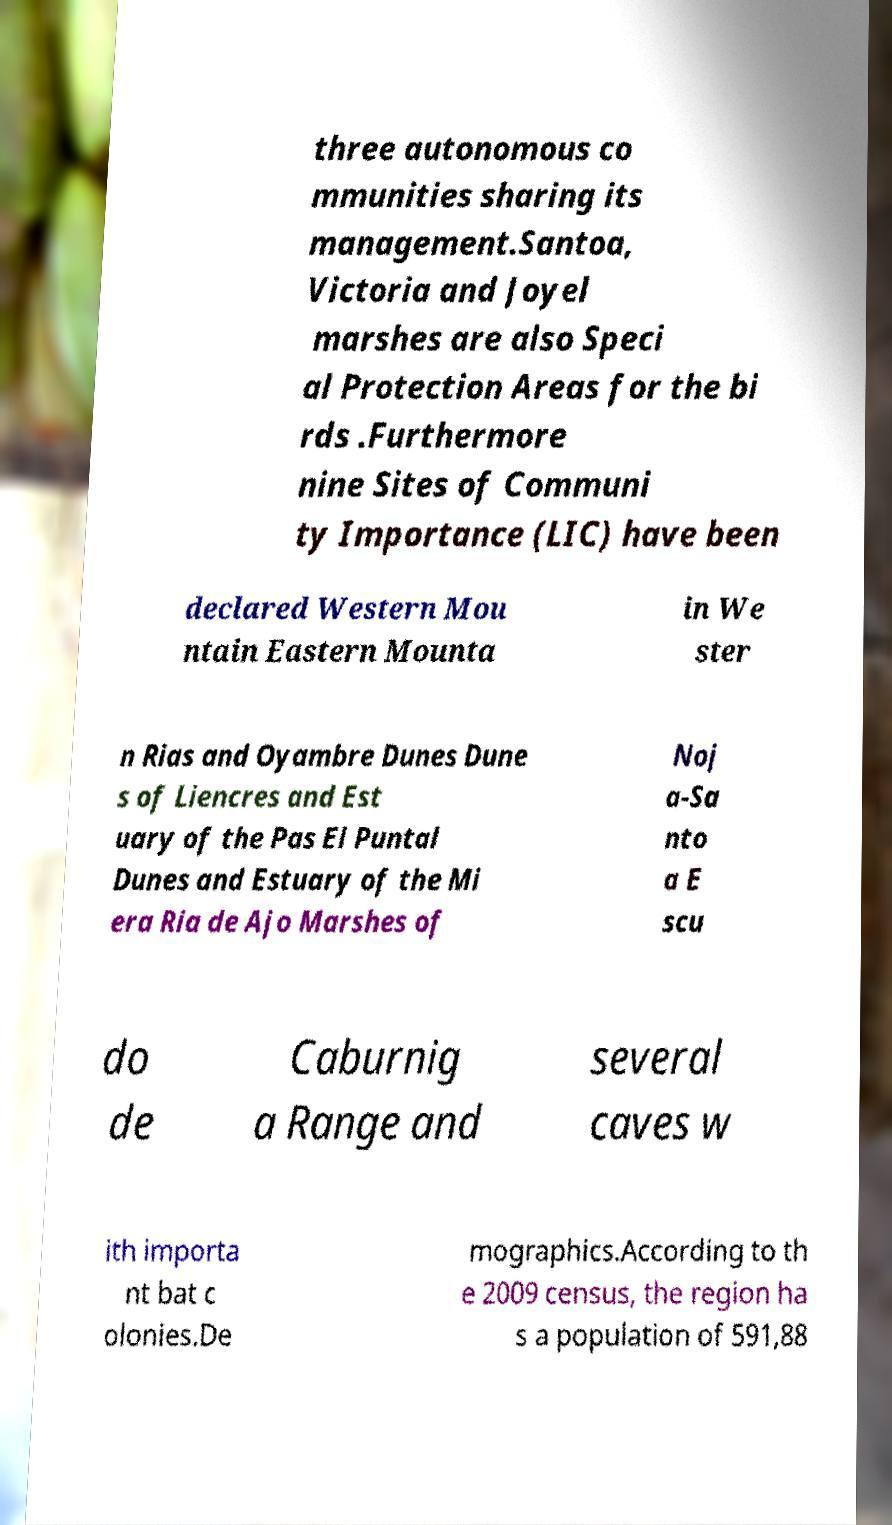I need the written content from this picture converted into text. Can you do that? three autonomous co mmunities sharing its management.Santoa, Victoria and Joyel marshes are also Speci al Protection Areas for the bi rds .Furthermore nine Sites of Communi ty Importance (LIC) have been declared Western Mou ntain Eastern Mounta in We ster n Rias and Oyambre Dunes Dune s of Liencres and Est uary of the Pas El Puntal Dunes and Estuary of the Mi era Ria de Ajo Marshes of Noj a-Sa nto a E scu do de Caburnig a Range and several caves w ith importa nt bat c olonies.De mographics.According to th e 2009 census, the region ha s a population of 591,88 